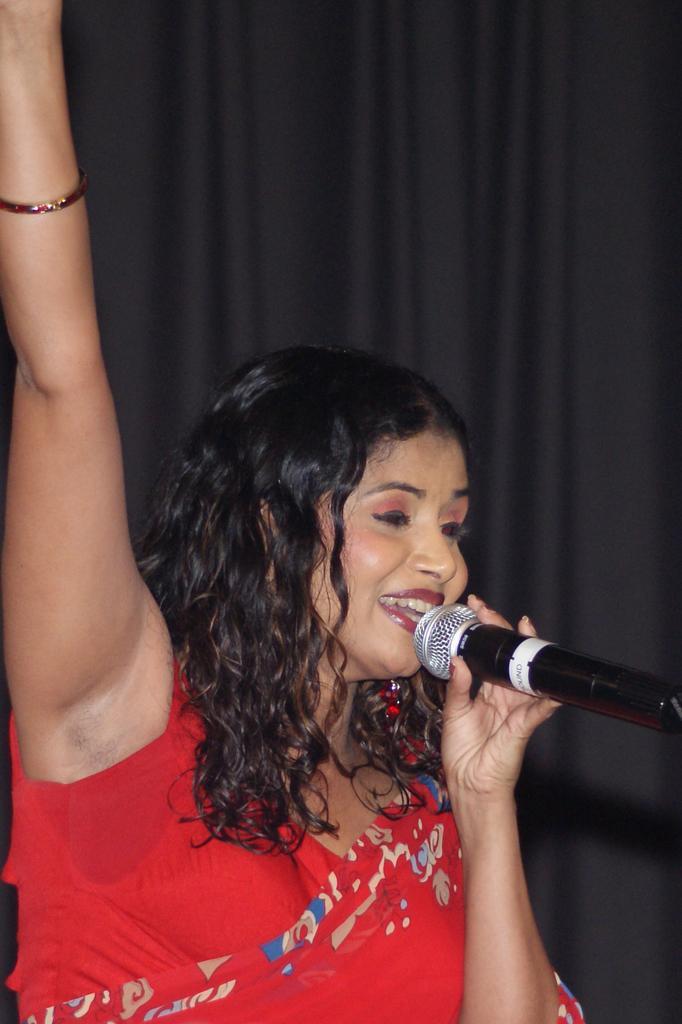How would you summarize this image in a sentence or two? a person is wearing a red dress and holding a microphone in her hand. 